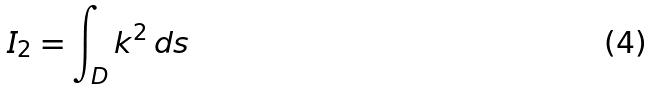<formula> <loc_0><loc_0><loc_500><loc_500>I _ { 2 } = \int _ { D } k ^ { 2 } \, d s</formula> 